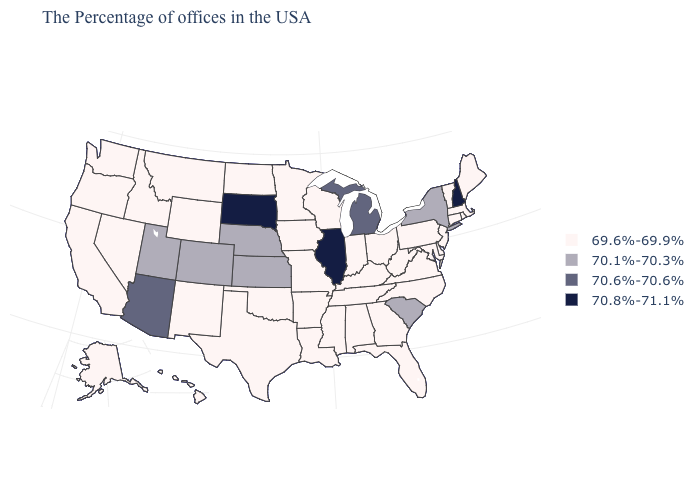Does Kansas have the lowest value in the USA?
Answer briefly. No. Does the first symbol in the legend represent the smallest category?
Keep it brief. Yes. Among the states that border Kansas , which have the highest value?
Answer briefly. Nebraska, Colorado. Name the states that have a value in the range 70.8%-71.1%?
Write a very short answer. New Hampshire, Illinois, South Dakota. Which states have the lowest value in the Northeast?
Concise answer only. Maine, Massachusetts, Rhode Island, Vermont, Connecticut, New Jersey, Pennsylvania. What is the value of Pennsylvania?
Quick response, please. 69.6%-69.9%. Name the states that have a value in the range 70.6%-70.6%?
Concise answer only. Michigan, Arizona. Among the states that border Colorado , does Arizona have the highest value?
Quick response, please. Yes. Which states have the lowest value in the South?
Quick response, please. Delaware, Maryland, Virginia, North Carolina, West Virginia, Florida, Georgia, Kentucky, Alabama, Tennessee, Mississippi, Louisiana, Arkansas, Oklahoma, Texas. What is the value of Florida?
Be succinct. 69.6%-69.9%. Name the states that have a value in the range 70.1%-70.3%?
Short answer required. New York, South Carolina, Kansas, Nebraska, Colorado, Utah. What is the lowest value in the USA?
Write a very short answer. 69.6%-69.9%. Does New Hampshire have the highest value in the USA?
Quick response, please. Yes. What is the value of Oregon?
Write a very short answer. 69.6%-69.9%. 